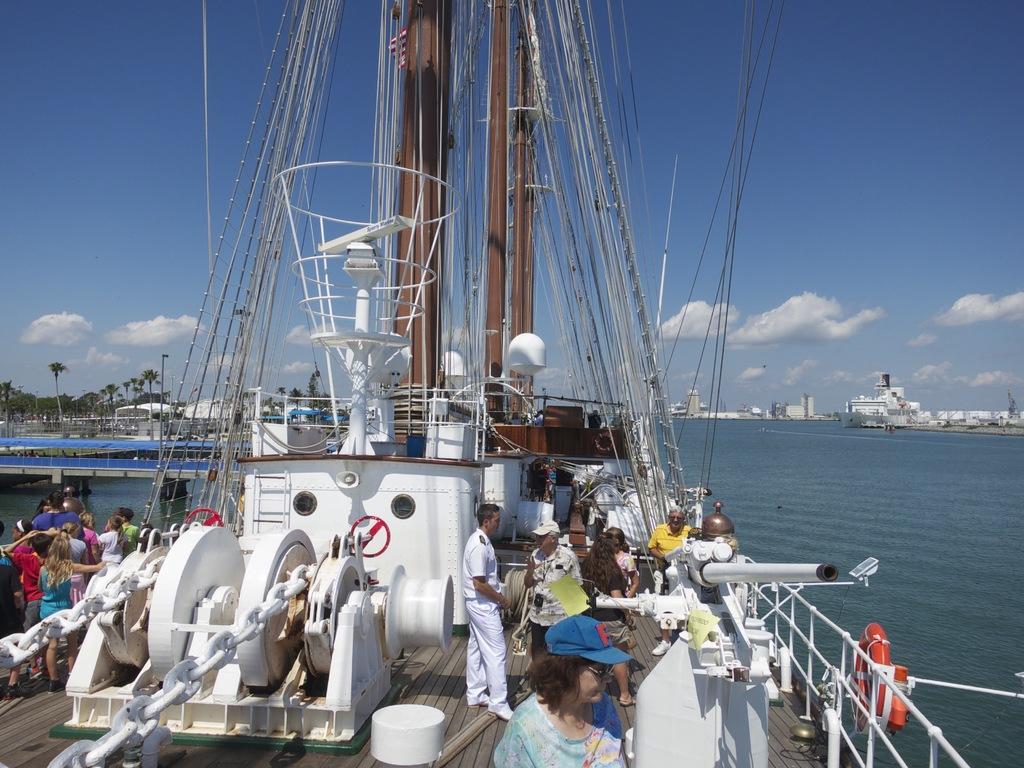Describe this image in one or two sentences. In the background we can see the clouds in the sky. In this picture we can see the trees, buildings, water and few objects. We can see a ship, people, poles, railing, metal chains and a flag is visible. 